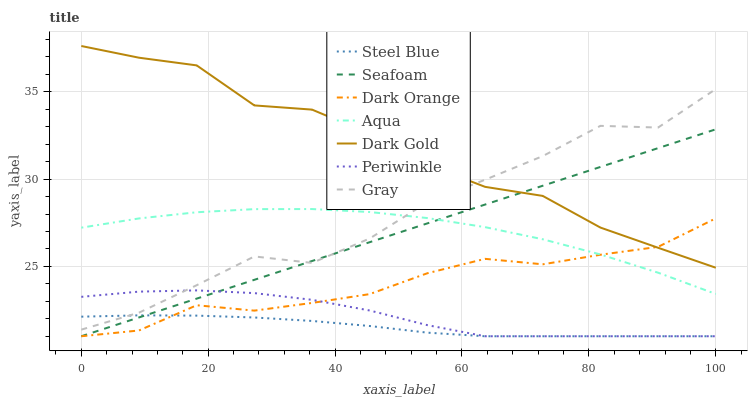Does Steel Blue have the minimum area under the curve?
Answer yes or no. Yes. Does Dark Gold have the maximum area under the curve?
Answer yes or no. Yes. Does Aqua have the minimum area under the curve?
Answer yes or no. No. Does Aqua have the maximum area under the curve?
Answer yes or no. No. Is Seafoam the smoothest?
Answer yes or no. Yes. Is Gray the roughest?
Answer yes or no. Yes. Is Dark Gold the smoothest?
Answer yes or no. No. Is Dark Gold the roughest?
Answer yes or no. No. Does Dark Orange have the lowest value?
Answer yes or no. Yes. Does Aqua have the lowest value?
Answer yes or no. No. Does Dark Gold have the highest value?
Answer yes or no. Yes. Does Aqua have the highest value?
Answer yes or no. No. Is Steel Blue less than Aqua?
Answer yes or no. Yes. Is Dark Gold greater than Periwinkle?
Answer yes or no. Yes. Does Gray intersect Aqua?
Answer yes or no. Yes. Is Gray less than Aqua?
Answer yes or no. No. Is Gray greater than Aqua?
Answer yes or no. No. Does Steel Blue intersect Aqua?
Answer yes or no. No. 